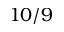<formula> <loc_0><loc_0><loc_500><loc_500>1 0 / 9</formula> 